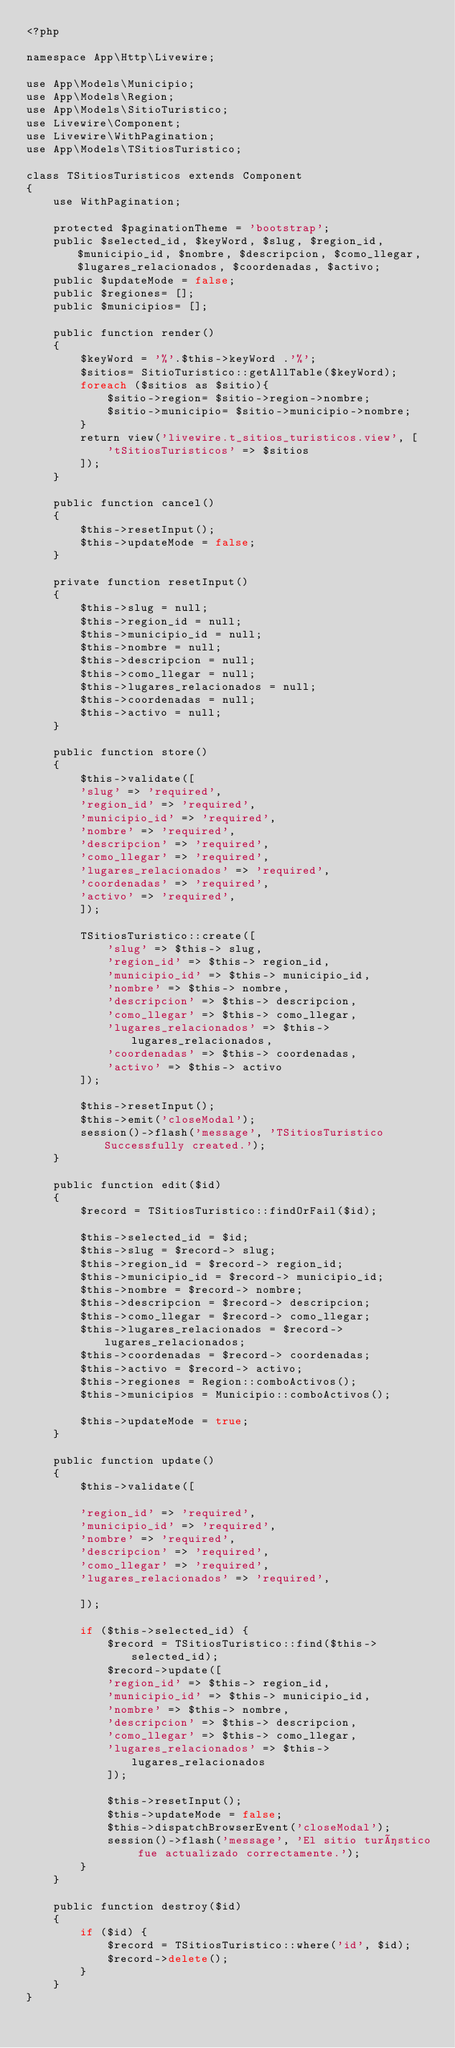<code> <loc_0><loc_0><loc_500><loc_500><_PHP_><?php

namespace App\Http\Livewire;

use App\Models\Municipio;
use App\Models\Region;
use App\Models\SitioTuristico;
use Livewire\Component;
use Livewire\WithPagination;
use App\Models\TSitiosTuristico;

class TSitiosTuristicos extends Component
{
    use WithPagination;

	protected $paginationTheme = 'bootstrap';
    public $selected_id, $keyWord, $slug, $region_id, $municipio_id, $nombre, $descripcion, $como_llegar, $lugares_relacionados, $coordenadas, $activo;
    public $updateMode = false;
    public $regiones= [];
    public $municipios= [];

    public function render()
    {
		$keyWord = '%'.$this->keyWord .'%';
        $sitios= SitioTuristico::getAllTable($keyWord);
        foreach ($sitios as $sitio){
            $sitio->region= $sitio->region->nombre;
            $sitio->municipio= $sitio->municipio->nombre;
        }
        return view('livewire.t_sitios_turisticos.view', [
            'tSitiosTuristicos' => $sitios
        ]);
    }

    public function cancel()
    {
        $this->resetInput();
        $this->updateMode = false;
    }

    private function resetInput()
    {
		$this->slug = null;
		$this->region_id = null;
		$this->municipio_id = null;
		$this->nombre = null;
		$this->descripcion = null;
		$this->como_llegar = null;
		$this->lugares_relacionados = null;
		$this->coordenadas = null;
		$this->activo = null;
    }

    public function store()
    {
        $this->validate([
		'slug' => 'required',
		'region_id' => 'required',
		'municipio_id' => 'required',
		'nombre' => 'required',
		'descripcion' => 'required',
		'como_llegar' => 'required',
		'lugares_relacionados' => 'required',
		'coordenadas' => 'required',
		'activo' => 'required',
        ]);

        TSitiosTuristico::create([
			'slug' => $this-> slug,
			'region_id' => $this-> region_id,
			'municipio_id' => $this-> municipio_id,
			'nombre' => $this-> nombre,
			'descripcion' => $this-> descripcion,
			'como_llegar' => $this-> como_llegar,
			'lugares_relacionados' => $this-> lugares_relacionados,
			'coordenadas' => $this-> coordenadas,
			'activo' => $this-> activo
        ]);

        $this->resetInput();
		$this->emit('closeModal');
		session()->flash('message', 'TSitiosTuristico Successfully created.');
    }

    public function edit($id)
    {
        $record = TSitiosTuristico::findOrFail($id);

        $this->selected_id = $id;
		$this->slug = $record-> slug;
		$this->region_id = $record-> region_id;
		$this->municipio_id = $record-> municipio_id;
		$this->nombre = $record-> nombre;
		$this->descripcion = $record-> descripcion;
		$this->como_llegar = $record-> como_llegar;
		$this->lugares_relacionados = $record-> lugares_relacionados;
		$this->coordenadas = $record-> coordenadas;
		$this->activo = $record-> activo;
        $this->regiones = Region::comboActivos();
        $this->municipios = Municipio::comboActivos();

        $this->updateMode = true;
    }

    public function update()
    {
        $this->validate([

		'region_id' => 'required',
		'municipio_id' => 'required',
		'nombre' => 'required',
		'descripcion' => 'required',
		'como_llegar' => 'required',
		'lugares_relacionados' => 'required',

        ]);

        if ($this->selected_id) {
			$record = TSitiosTuristico::find($this->selected_id);
            $record->update([
			'region_id' => $this-> region_id,
			'municipio_id' => $this-> municipio_id,
			'nombre' => $this-> nombre,
			'descripcion' => $this-> descripcion,
			'como_llegar' => $this-> como_llegar,
			'lugares_relacionados' => $this-> lugares_relacionados
            ]);

            $this->resetInput();
            $this->updateMode = false;
            $this->dispatchBrowserEvent('closeModal');
            session()->flash('message', 'El sitio turístico fue actualizado correctamente.');
        }
    }

    public function destroy($id)
    {
        if ($id) {
            $record = TSitiosTuristico::where('id', $id);
            $record->delete();
        }
    }
}
</code> 